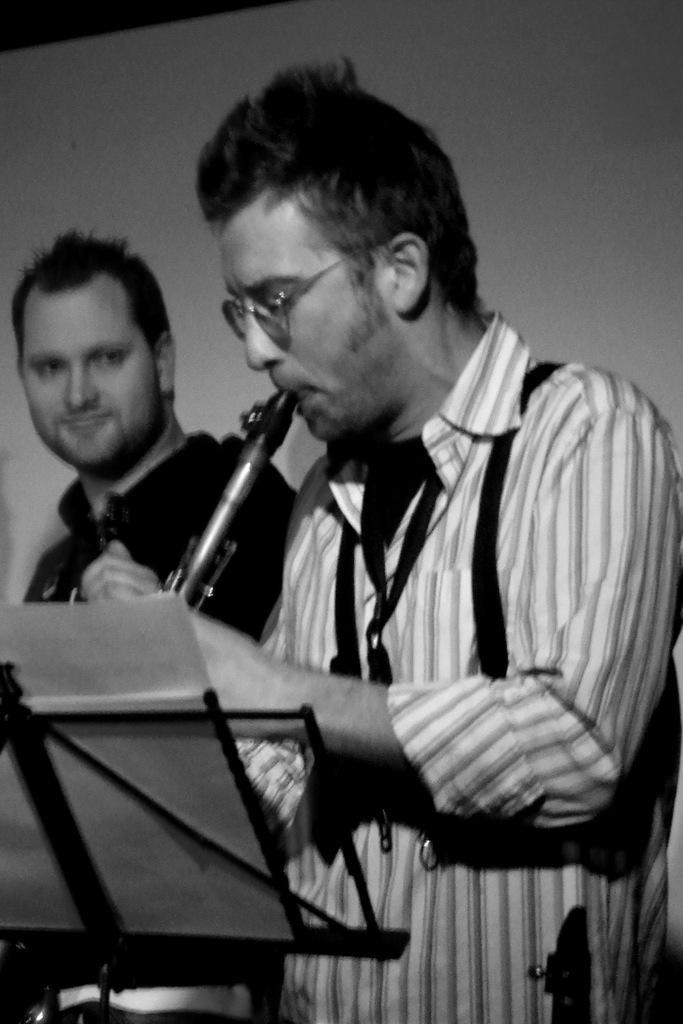Could you give a brief overview of what you see in this image? In this image we can see two persons, one of them is playing a musical instrument, there are papers on the stand, also we can see the wall, and the picture is taken in black and white mode. 